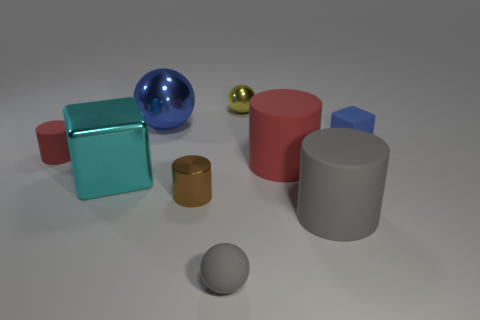Is the number of gray rubber cylinders to the right of the small gray ball greater than the number of large brown metal cylinders?
Provide a succinct answer. Yes. There is a tiny ball that is in front of the cyan metallic thing; how many tiny red objects are right of it?
Ensure brevity in your answer.  0. What is the shape of the blue object that is left of the big gray cylinder right of the tiny yellow metallic thing that is to the right of the tiny red rubber cylinder?
Provide a short and direct response. Sphere. How big is the blue block?
Ensure brevity in your answer.  Small. Is there a big red ball that has the same material as the large blue sphere?
Offer a terse response. No. What is the size of the gray matte thing that is the same shape as the big red object?
Your response must be concise. Large. Are there an equal number of big metallic cubes to the left of the cyan thing and small green cylinders?
Give a very brief answer. Yes. There is a big shiny object in front of the small blue rubber block; is it the same shape as the small blue rubber thing?
Provide a succinct answer. Yes. What is the shape of the tiny yellow shiny object?
Your answer should be compact. Sphere. The small object behind the small object to the right of the red cylinder that is on the right side of the tiny gray sphere is made of what material?
Provide a succinct answer. Metal. 